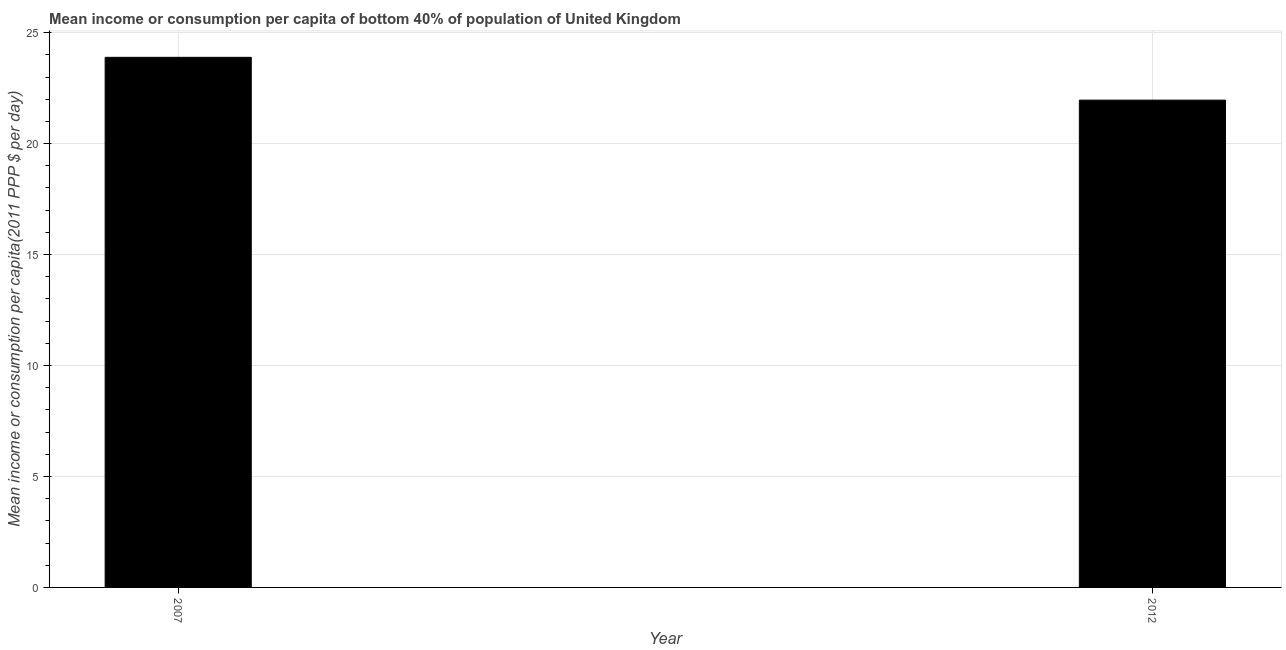What is the title of the graph?
Offer a terse response. Mean income or consumption per capita of bottom 40% of population of United Kingdom. What is the label or title of the Y-axis?
Offer a terse response. Mean income or consumption per capita(2011 PPP $ per day). What is the mean income or consumption in 2012?
Provide a short and direct response. 21.96. Across all years, what is the maximum mean income or consumption?
Keep it short and to the point. 23.89. Across all years, what is the minimum mean income or consumption?
Make the answer very short. 21.96. What is the sum of the mean income or consumption?
Keep it short and to the point. 45.84. What is the difference between the mean income or consumption in 2007 and 2012?
Your answer should be compact. 1.93. What is the average mean income or consumption per year?
Provide a succinct answer. 22.92. What is the median mean income or consumption?
Offer a very short reply. 22.92. In how many years, is the mean income or consumption greater than 22 $?
Keep it short and to the point. 1. Do a majority of the years between 2007 and 2012 (inclusive) have mean income or consumption greater than 10 $?
Offer a very short reply. Yes. What is the ratio of the mean income or consumption in 2007 to that in 2012?
Your answer should be very brief. 1.09. In how many years, is the mean income or consumption greater than the average mean income or consumption taken over all years?
Provide a short and direct response. 1. How many years are there in the graph?
Your answer should be very brief. 2. Are the values on the major ticks of Y-axis written in scientific E-notation?
Provide a succinct answer. No. What is the Mean income or consumption per capita(2011 PPP $ per day) in 2007?
Provide a short and direct response. 23.89. What is the Mean income or consumption per capita(2011 PPP $ per day) in 2012?
Give a very brief answer. 21.96. What is the difference between the Mean income or consumption per capita(2011 PPP $ per day) in 2007 and 2012?
Offer a very short reply. 1.93. What is the ratio of the Mean income or consumption per capita(2011 PPP $ per day) in 2007 to that in 2012?
Give a very brief answer. 1.09. 